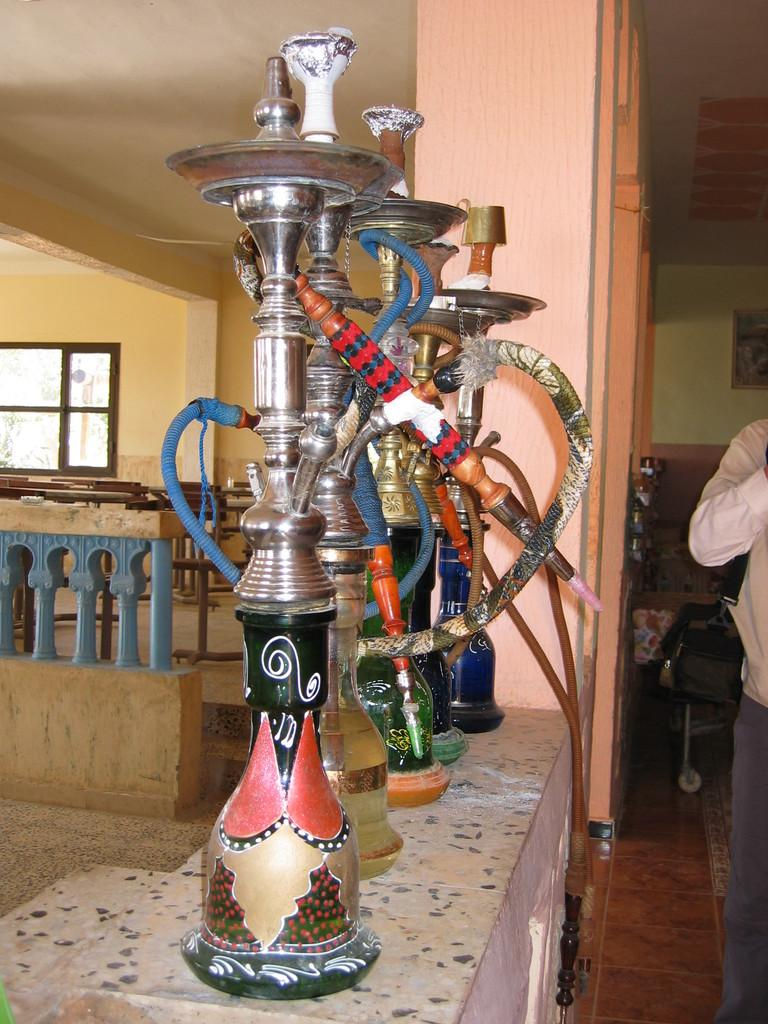What is the main subject in the image? There is a person standing in the image. What objects are associated with the person in the image? Hookah pots are visible in the image. What can be seen in the background of the image? There is a wall and a window in the background of the image. What type of quartz is being used to light the hookah pots in the image? There is no quartz present in the image, and the hookah pots are not being lit. 